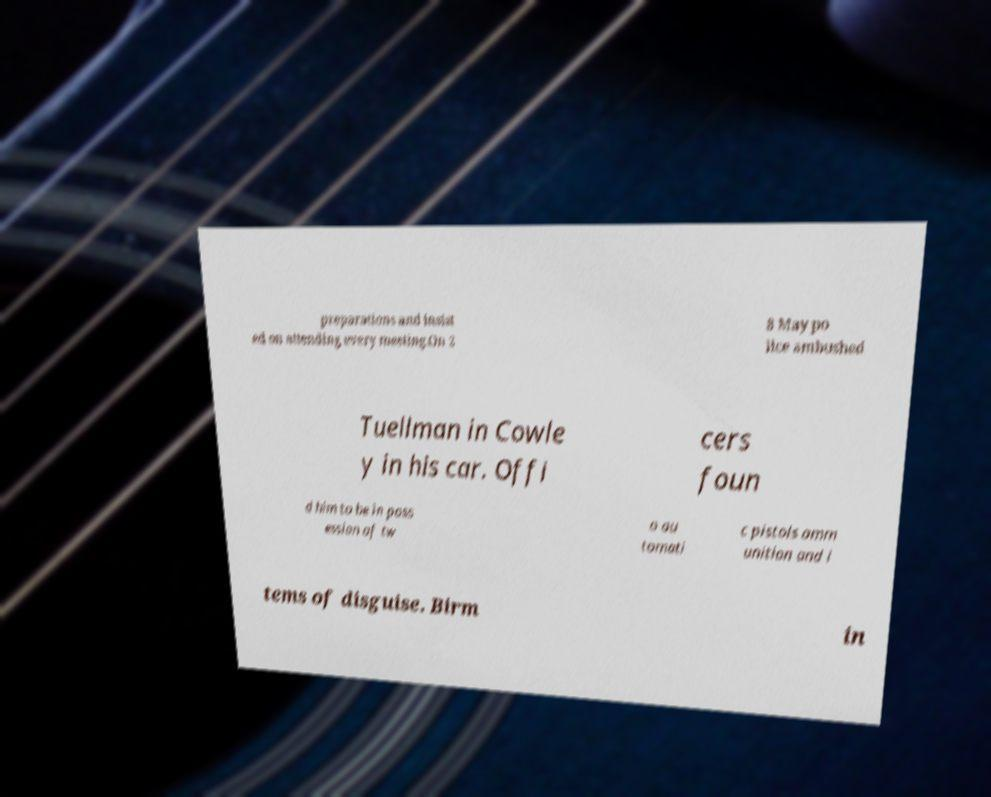For documentation purposes, I need the text within this image transcribed. Could you provide that? preparations and insist ed on attending every meeting.On 2 8 May po lice ambushed Tuellman in Cowle y in his car. Offi cers foun d him to be in poss ession of tw o au tomati c pistols amm unition and i tems of disguise. Birm in 